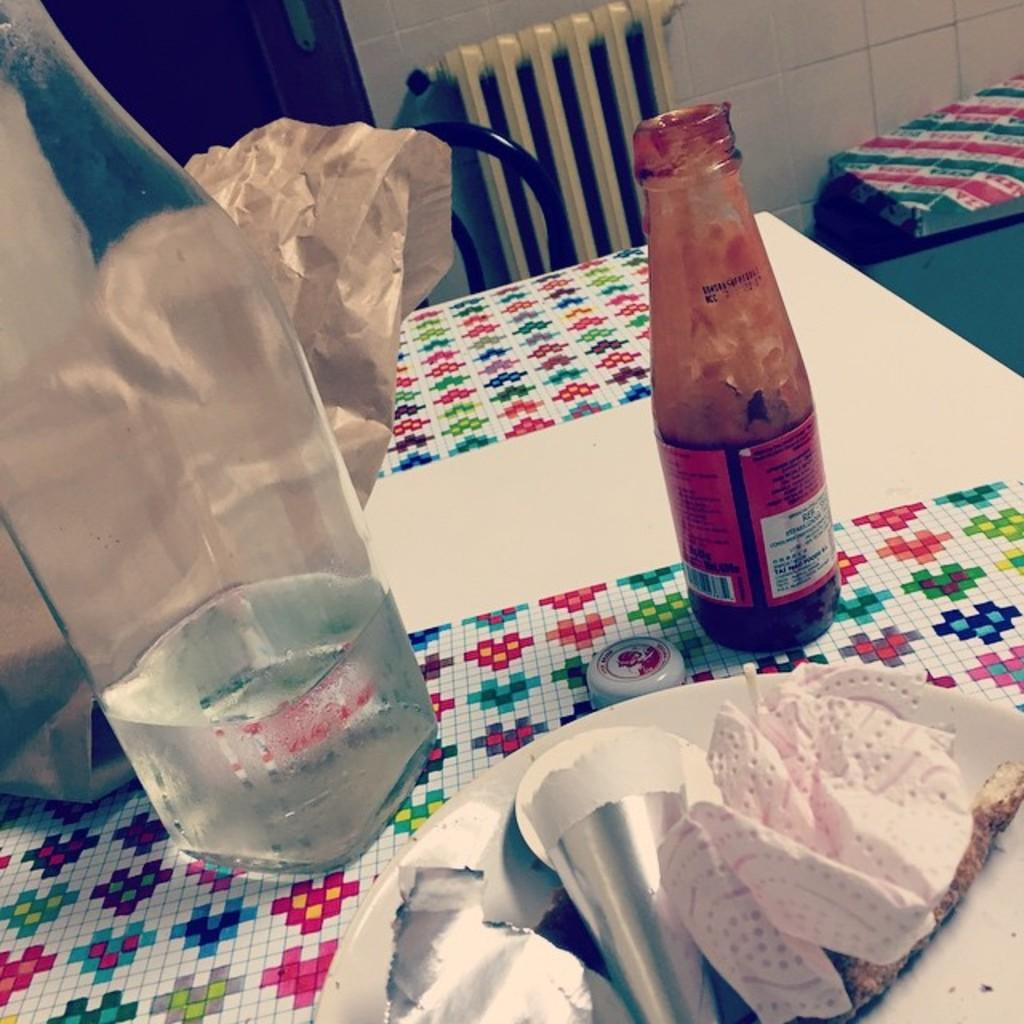What is the color of the table in the image? The table in the image is white. What is placed on the table? There are plates on the table. What is on top of the plates? The plates have tissue and wrappers on them. What type of container is filled with liquid in the image? There is a bottle with liquid in the image. What condiment is present in the image? There is a ketchup bottle in the image. What type of natural formation is visible in the image? There is a cove in the image. What piece of furniture is located behind the table? There is a chair behind the table in the image. How many zippers can be seen on the table in the image? There are no zippers visible on the table in the image. What type of animal is grazing in the cove in the image? There are no animals present in the image, and the cove does not depict a grazing area. 